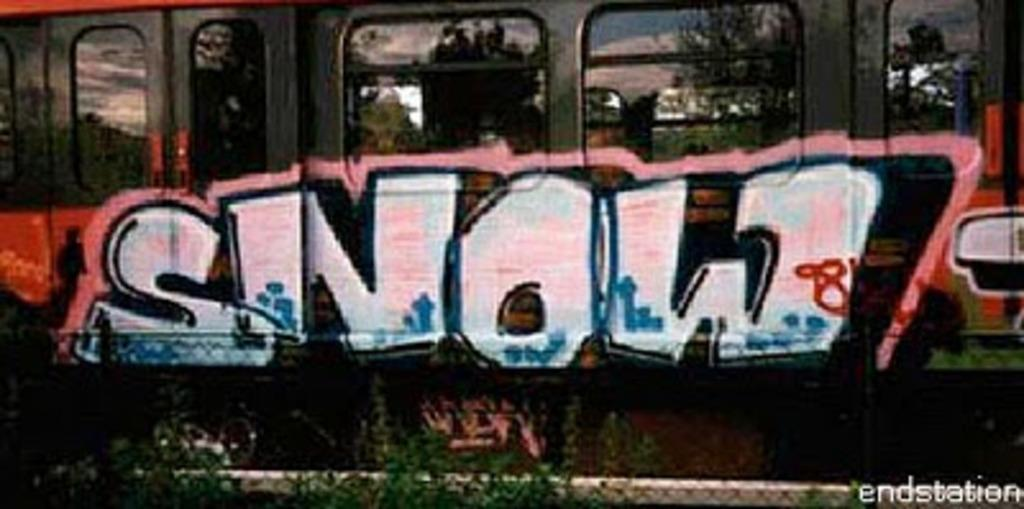Provide a one-sentence caption for the provided image. Graffiti on a train that says the word "snow". 